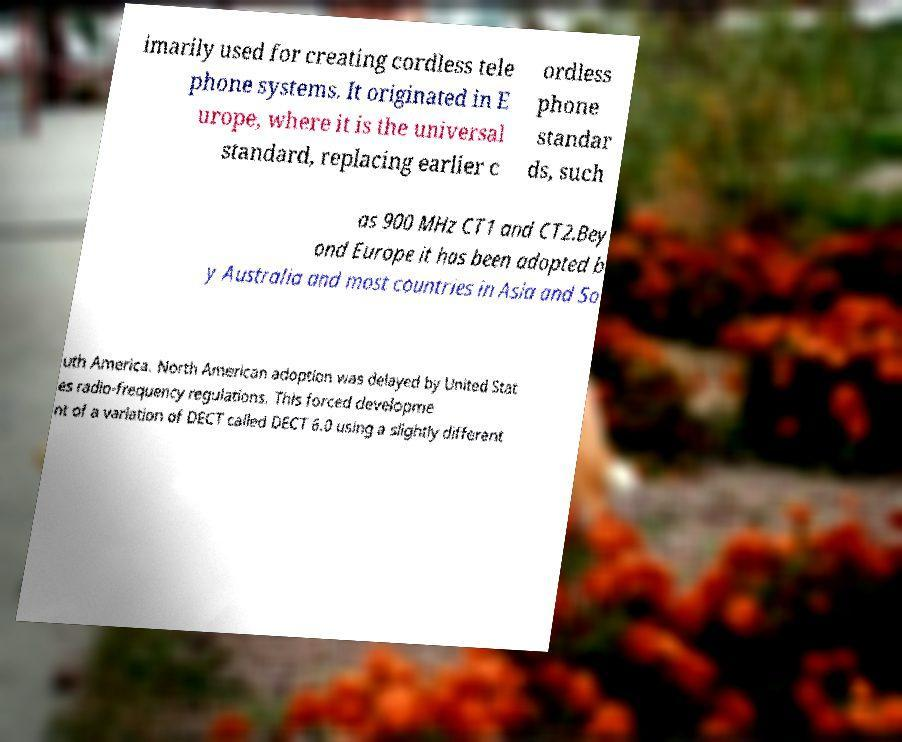For documentation purposes, I need the text within this image transcribed. Could you provide that? imarily used for creating cordless tele phone systems. It originated in E urope, where it is the universal standard, replacing earlier c ordless phone standar ds, such as 900 MHz CT1 and CT2.Bey ond Europe it has been adopted b y Australia and most countries in Asia and So uth America. North American adoption was delayed by United Stat es radio-frequency regulations. This forced developme nt of a variation of DECT called DECT 6.0 using a slightly different 